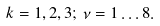<formula> <loc_0><loc_0><loc_500><loc_500>k = 1 , 2 , 3 ; \, \nu = 1 \dots 8 .</formula> 